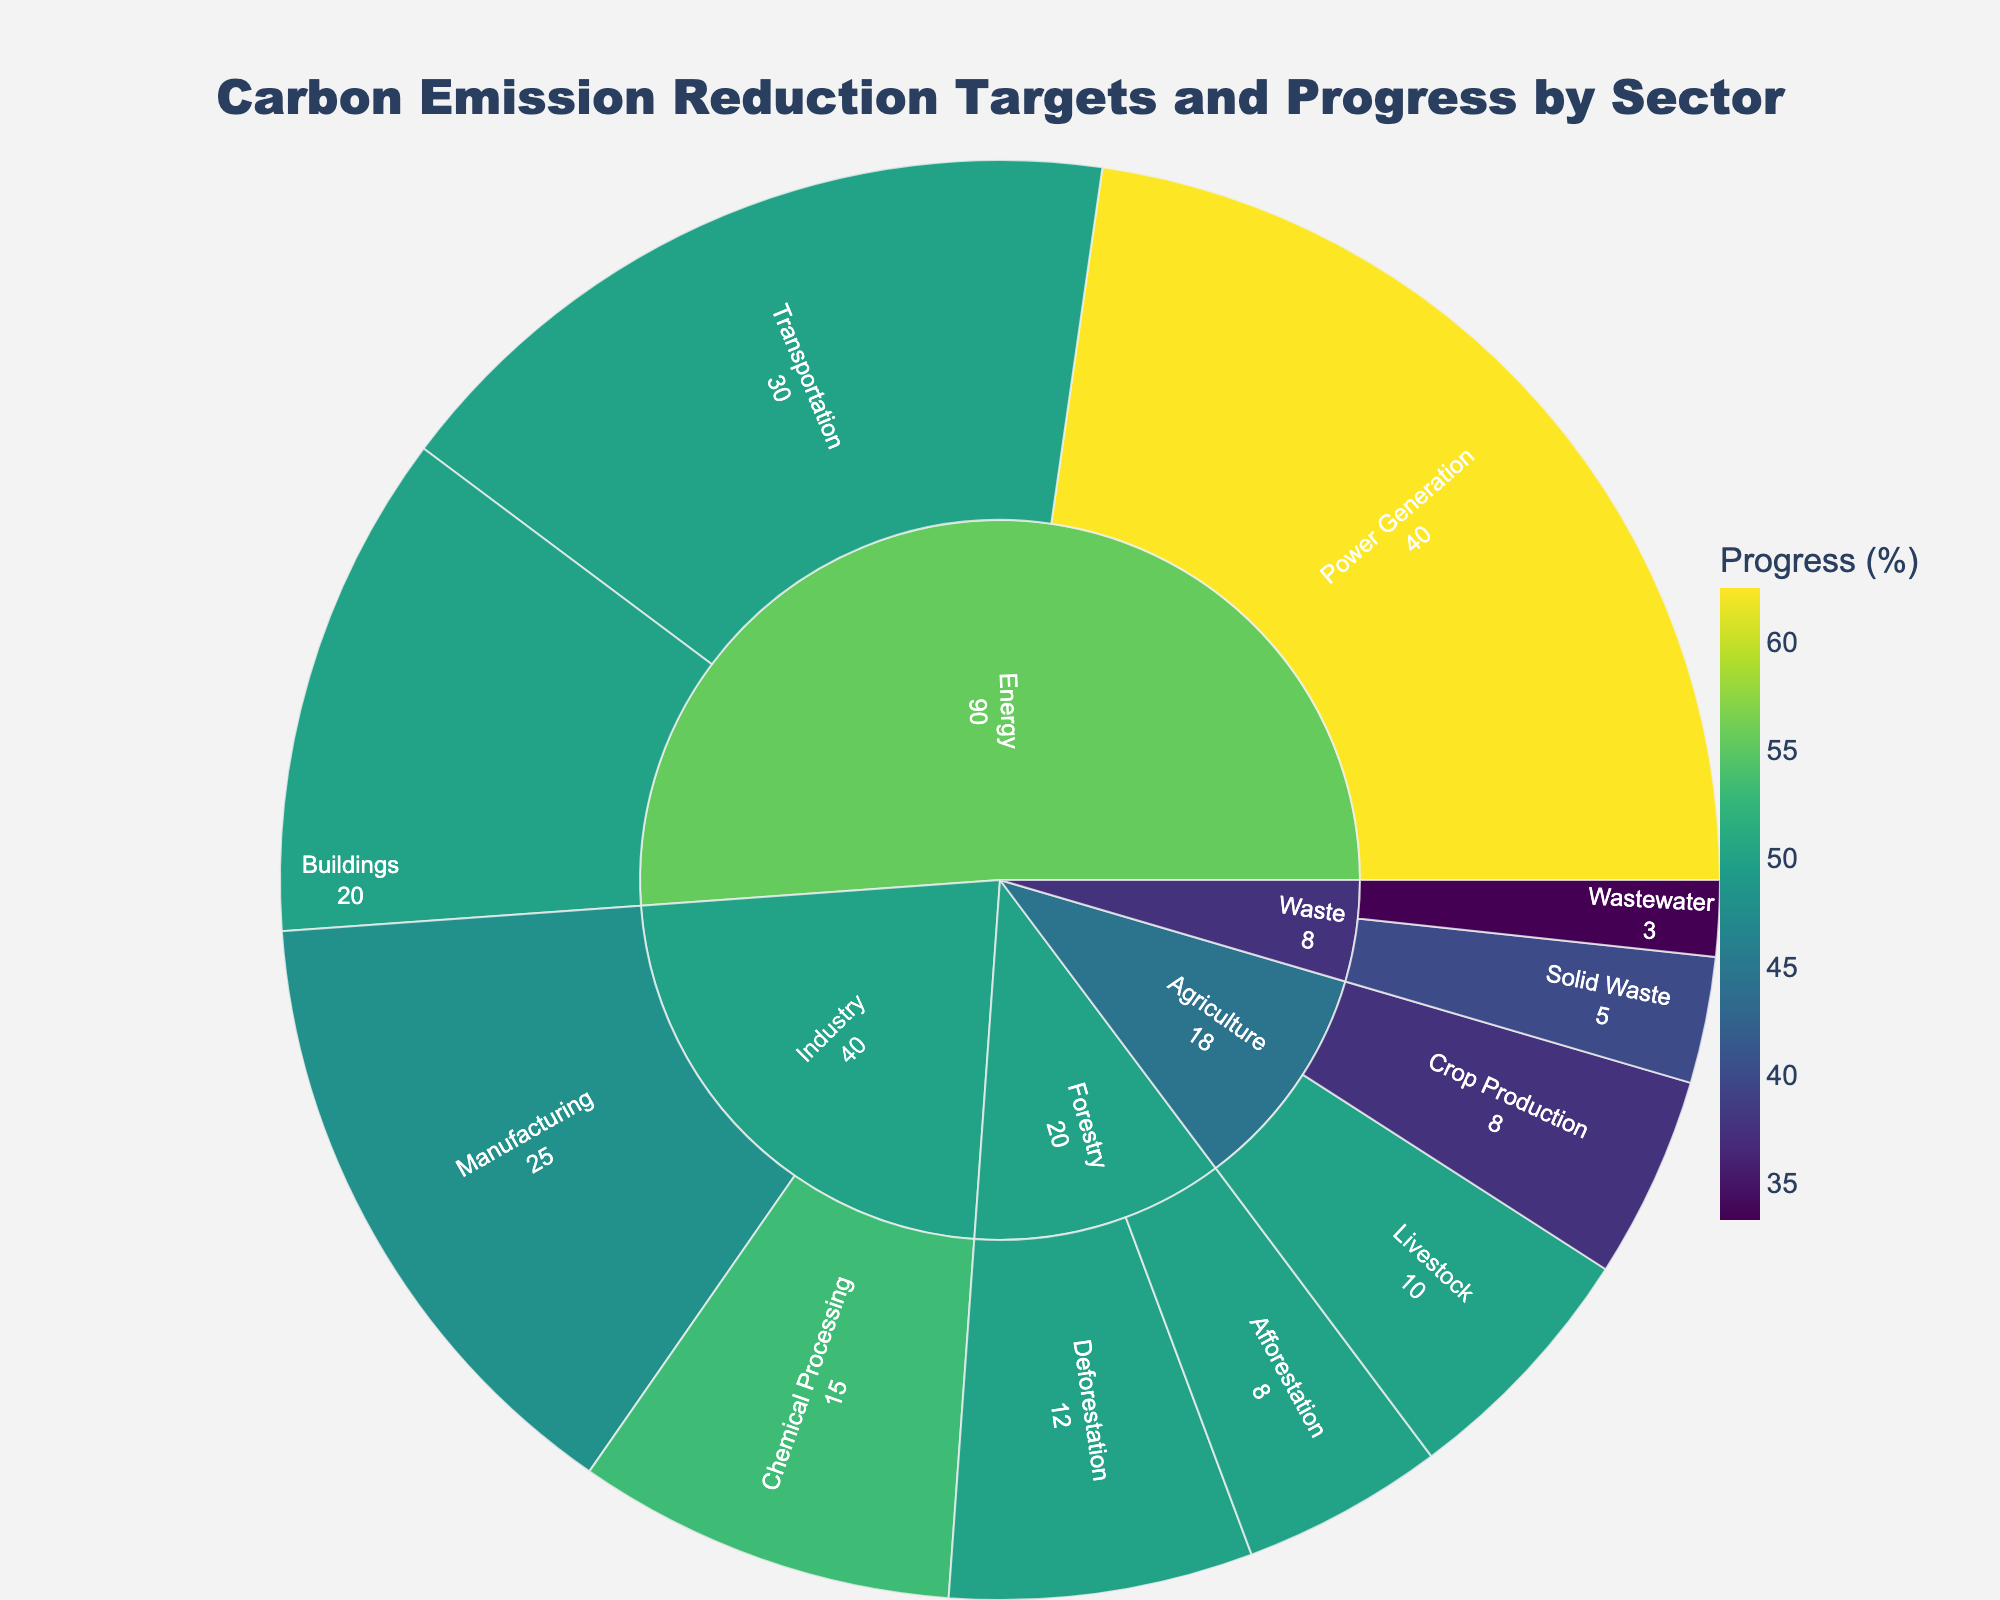Who has set the highest carbon emission reduction target among the sectors? The Energy sector, which includes Power Generation, Transportation, and Buildings, has set the highest total target. The specific targets for Power Generation, Transportation, and Buildings are 40, 30, and 20, respectively, summing up to 90.
Answer: Energy Which subsector shows the highest progress in terms of percentage towards its target? The subsector with the highest progress percentage is Power Generation within the Energy sector, with 25 units of progress out of a 40-unit target, equating to 62.5%.
Answer: Power Generation What is the target and actual progress of the Forestry sector in percentage? The Forestry sector has a target of 12 (Deforestation) + 8 (Afforestation) = 20. The actual progress is 6 (Deforestation) + 4 (Afforestation) = 10. Therefore, the overall progress percentage is (10 / 20) * 100% = 50%.
Answer: 50% How does the progress of the Transportation subsector compare to that of Building subsector within the Energy sector? The Transportation subsector has a progress of 15 out of a 30 target (50%), while the Buildings subsector has a progress of 10 out of a 20 target (50%). They have the same progress percentage.
Answer: Equal Which sector's subsectors cumulatively contribute the least to the carbon emission reduction target? The Waste sector’s subsectors, Solid Waste and Wastewater, have targets of 5 and 3, respectively, making a total of 8, which is the smallest cumulative target.
Answer: Waste Which area has shown the least progress towards its 2030 target? The Wastewater subsector within the Waste sector has shown the least progress of only 1 unit towards its 3-unit target, translating to roughly 33.3%.
Answer: Wastewater What is the combined carbon emission reduction target for the Agriculture sector? The total target for the Agriculture sector, which includes Livestock (10) and Crop Production (8), is 18.
Answer: 18 Out of the sectors presented, which one has made the most strides in deforestation carbon reduction? The Forestry sector’s Deforestation subsector has achieved a progress of 6 units out of its 12-unit target, resulting in a 50% progress.
Answer: Deforestation Between Chemical Processing in Industry and Livestock in Agriculture, which has higher progress in actual units? The Chemical Processing subsector in Industry has made a progress of 8 units, while the Livestock subsector in Agriculture has made a progress of 5 units.
Answer: Chemical Processing 